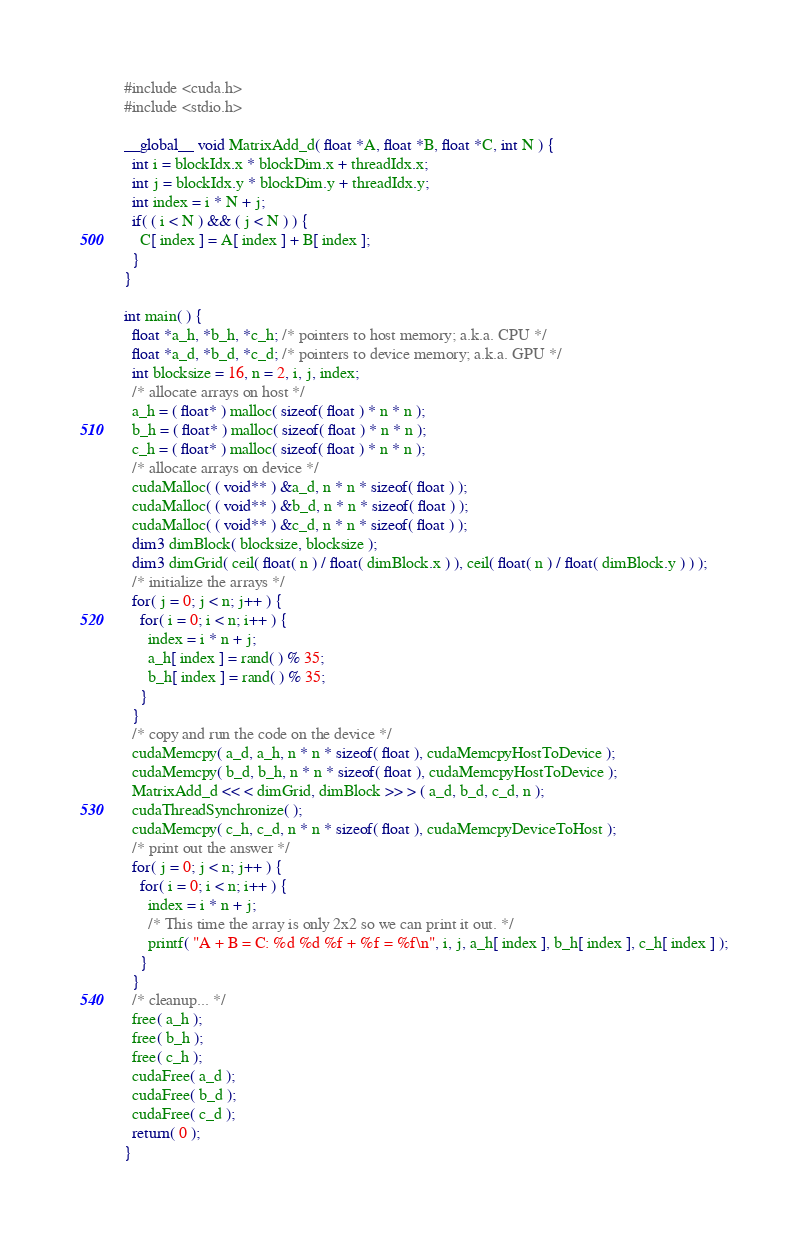Convert code to text. <code><loc_0><loc_0><loc_500><loc_500><_Cuda_>#include <cuda.h>
#include <stdio.h>

__global__ void MatrixAdd_d( float *A, float *B, float *C, int N ) {
  int i = blockIdx.x * blockDim.x + threadIdx.x;
  int j = blockIdx.y * blockDim.y + threadIdx.y;
  int index = i * N + j;
  if( ( i < N ) && ( j < N ) ) {
    C[ index ] = A[ index ] + B[ index ];
  }
}

int main( ) {
  float *a_h, *b_h, *c_h; /* pointers to host memory; a.k.a. CPU */
  float *a_d, *b_d, *c_d; /* pointers to device memory; a.k.a. GPU */
  int blocksize = 16, n = 2, i, j, index;
  /* allocate arrays on host */
  a_h = ( float* ) malloc( sizeof( float ) * n * n );
  b_h = ( float* ) malloc( sizeof( float ) * n * n );
  c_h = ( float* ) malloc( sizeof( float ) * n * n );
  /* allocate arrays on device */
  cudaMalloc( ( void** ) &a_d, n * n * sizeof( float ) );
  cudaMalloc( ( void** ) &b_d, n * n * sizeof( float ) );
  cudaMalloc( ( void** ) &c_d, n * n * sizeof( float ) );
  dim3 dimBlock( blocksize, blocksize );
  dim3 dimGrid( ceil( float( n ) / float( dimBlock.x ) ), ceil( float( n ) / float( dimBlock.y ) ) );
  /* initialize the arrays */
  for( j = 0; j < n; j++ ) {
    for( i = 0; i < n; i++ ) {
      index = i * n + j;
      a_h[ index ] = rand( ) % 35;
      b_h[ index ] = rand( ) % 35;
    }
  }
  /* copy and run the code on the device */
  cudaMemcpy( a_d, a_h, n * n * sizeof( float ), cudaMemcpyHostToDevice );
  cudaMemcpy( b_d, b_h, n * n * sizeof( float ), cudaMemcpyHostToDevice );
  MatrixAdd_d << < dimGrid, dimBlock >> > ( a_d, b_d, c_d, n );
  cudaThreadSynchronize( );
  cudaMemcpy( c_h, c_d, n * n * sizeof( float ), cudaMemcpyDeviceToHost );
  /* print out the answer */
  for( j = 0; j < n; j++ ) {
    for( i = 0; i < n; i++ ) {
      index = i * n + j;
      /* This time the array is only 2x2 so we can print it out. */
      printf( "A + B = C: %d %d %f + %f = %f\n", i, j, a_h[ index ], b_h[ index ], c_h[ index ] );
    }
  }
  /* cleanup... */
  free( a_h );
  free( b_h );
  free( c_h );
  cudaFree( a_d );
  cudaFree( b_d );
  cudaFree( c_d );
  return( 0 );
}
</code> 